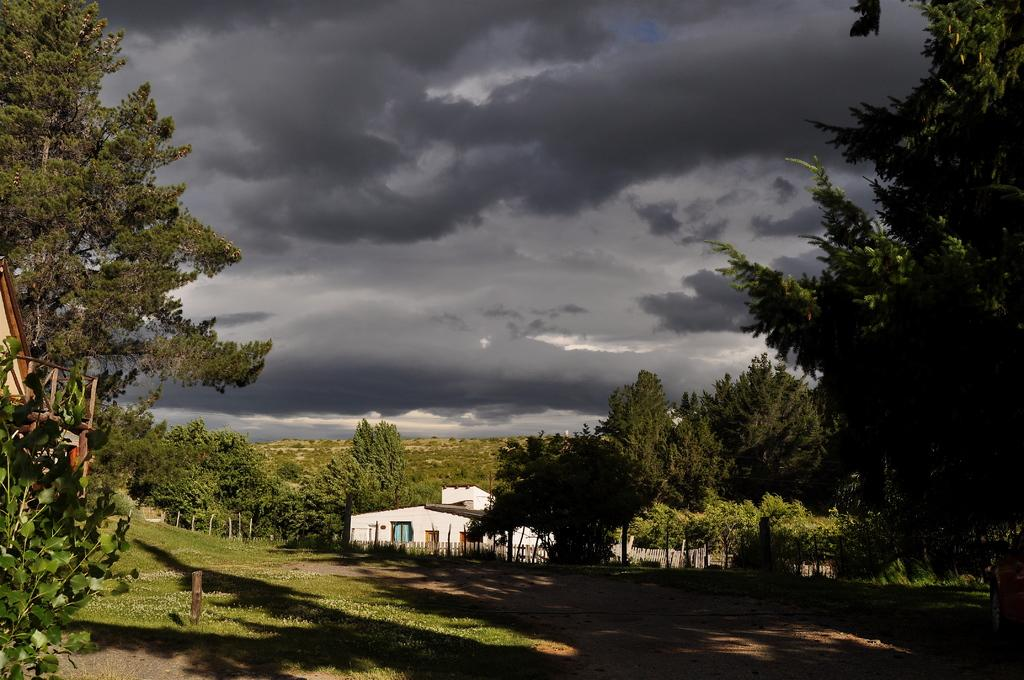What type of structure is present in the image? There is a house in the image. What other natural elements can be seen in the image? There are trees and grass visible in the image. What is visible in the background of the image? The sky is visible in the background of the image. How would you describe the sky in the image? The sky appears to be cloudy in the image. What is the reaction of the house to the cloudy sky in the image? The house is an inanimate object and does not have reactions; it simply remains stationary in the image. 